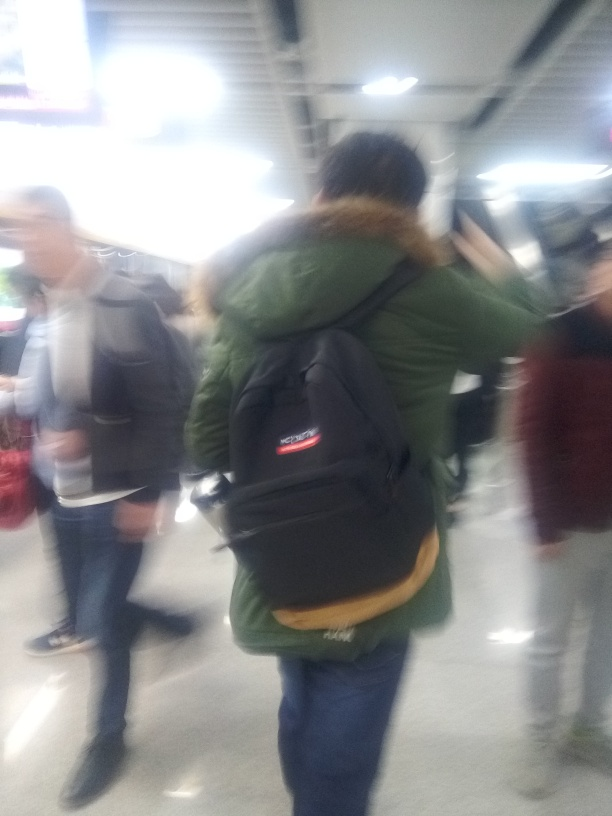What is the quality of this image? The image quality is quite low, showing significant motion blur and lack of focus which make it difficult to discern fine details. It seems that the photo was taken in a hurried or unstable manner, perhaps in low lighting, contributing to the blur. Despite these issues, it captures a candid moment in a busy setting, likely an indoor public space such as a transit hub. 